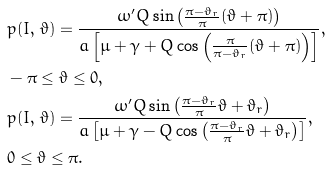Convert formula to latex. <formula><loc_0><loc_0><loc_500><loc_500>& p ( I , \, \vartheta ) = \frac { \omega ^ { \prime } Q \sin { \left ( \frac { \pi - \vartheta _ { r } } { \pi } ( \vartheta + \pi ) \right ) } } { a \left [ \mu + \gamma + Q \cos { \left ( \frac { \pi } { \pi - \vartheta _ { r } } ( \vartheta + \pi ) \right ) } \right ] } , \\ & - \pi \leq \vartheta \leq 0 , \\ & p ( I , \, \vartheta ) = \frac { \omega ^ { \prime } Q \sin { \left ( \frac { \pi - \vartheta _ { r } } { \pi } \vartheta + \vartheta _ { r } \right ) } } { a \left [ \mu + \gamma - Q \cos { \left ( \frac { \pi - \vartheta _ { r } } { \pi } \vartheta + \vartheta _ { r } \right ) } \right ] } , \\ & 0 \leq \vartheta \leq \pi .</formula> 